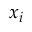<formula> <loc_0><loc_0><loc_500><loc_500>x _ { i }</formula> 